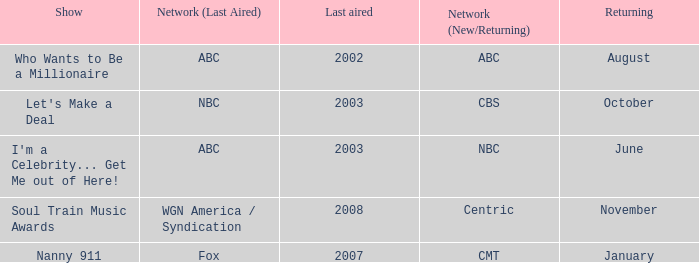When did a show last aired in 2002 return? August. 